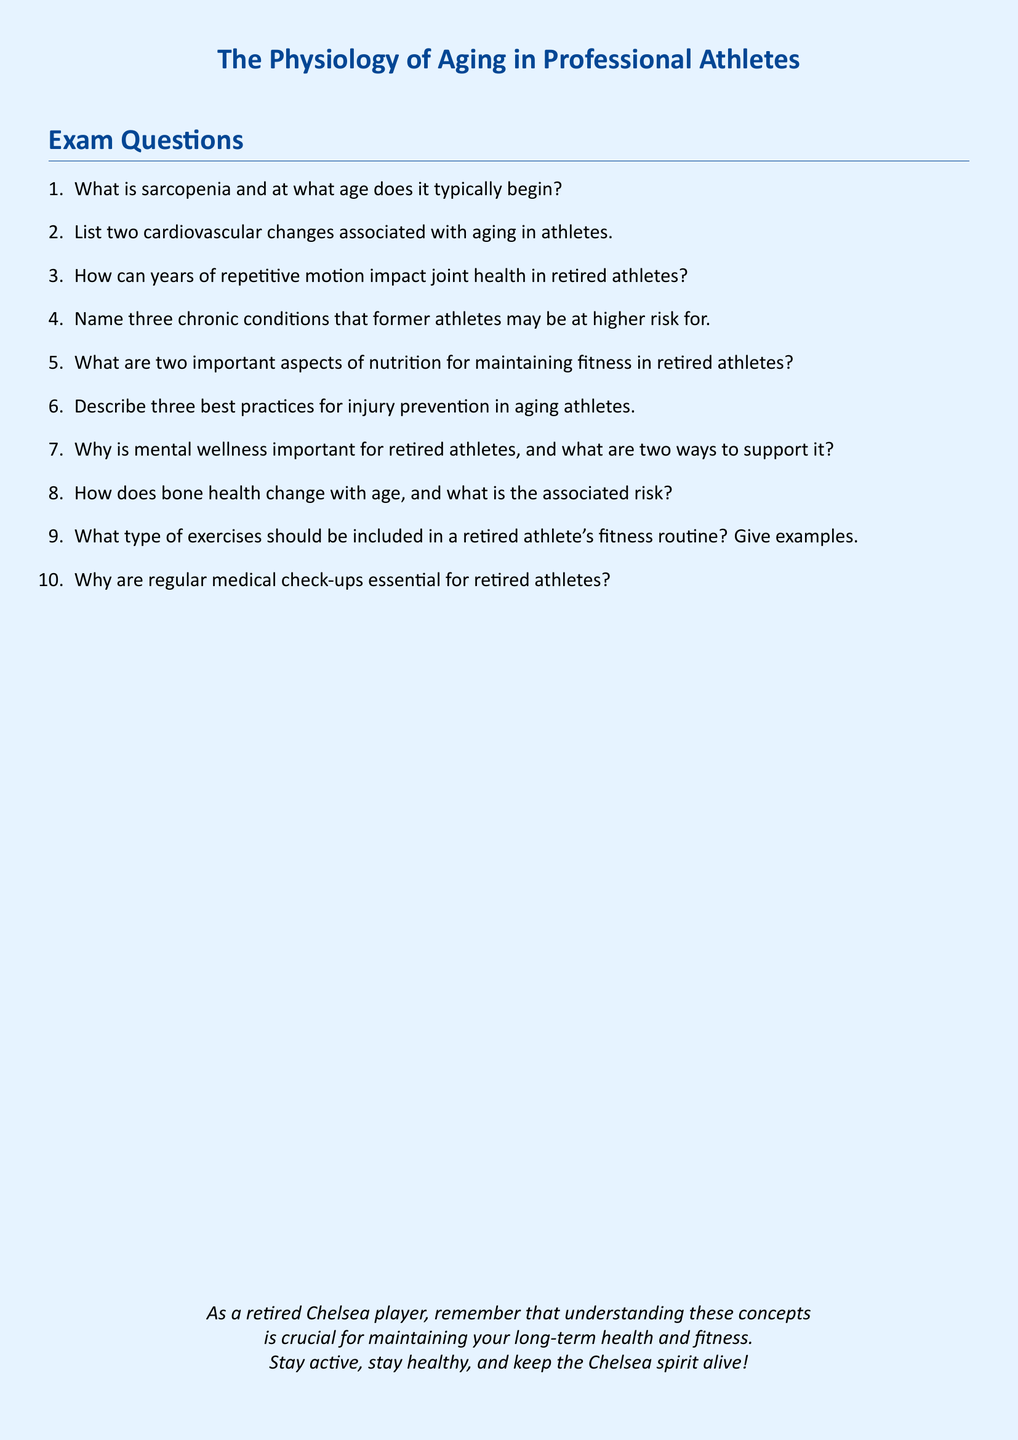What is the title of the document? The title of the document is presented at the beginning and provides the main topic of discussion, which is "The Physiology of Aging in Professional Athletes."
Answer: The Physiology of Aging in Professional Athletes At what age does sarcopenia typically begin? The document explicitly states the age range when sarcopenia begins, which is a key aspect of understanding aging in athletes.
Answer: 30 Name a type of exercise that should be included in a retired athlete's fitness routine. The document encourages including exercises and gives examples, so naming even one example demonstrates understanding.
Answer: Strength training What are two aspects of nutrition important for retired athletes? The document lists key nutritional factors that contribute to maintaining fitness, and answering this question shows grasp of essential dietary needs.
Answer: Protein, hydration How many chronic conditions are former athletes at higher risk for? The document highlights a specific number of chronic conditions to be aware of for retired athletes, emphasizing health risks post-career.
Answer: Three List one best practice for injury prevention in aging athletes. The document describes several practices to help with injury prevention, and naming one shows comprehension of the guidelines provided.
Answer: Regular stretching What is one cardiovascular change associated with aging in athletes? The document mentions specific cardiovascular changes that occur, so identifying one indicates attention to the discussed physiological changes.
Answer: Decreased maximum heart rate Why are regular medical check-ups essential for retired athletes? The document emphasizes the importance of health monitoring, pointing out reasons that underlie regular check-ups for this demographic.
Answer: Health monitoring What is one way to support mental wellness for retired athletes? The document offers methods for supporting mental wellness, so naming one shows awareness of its significance in post-career life.
Answer: Social engagement 